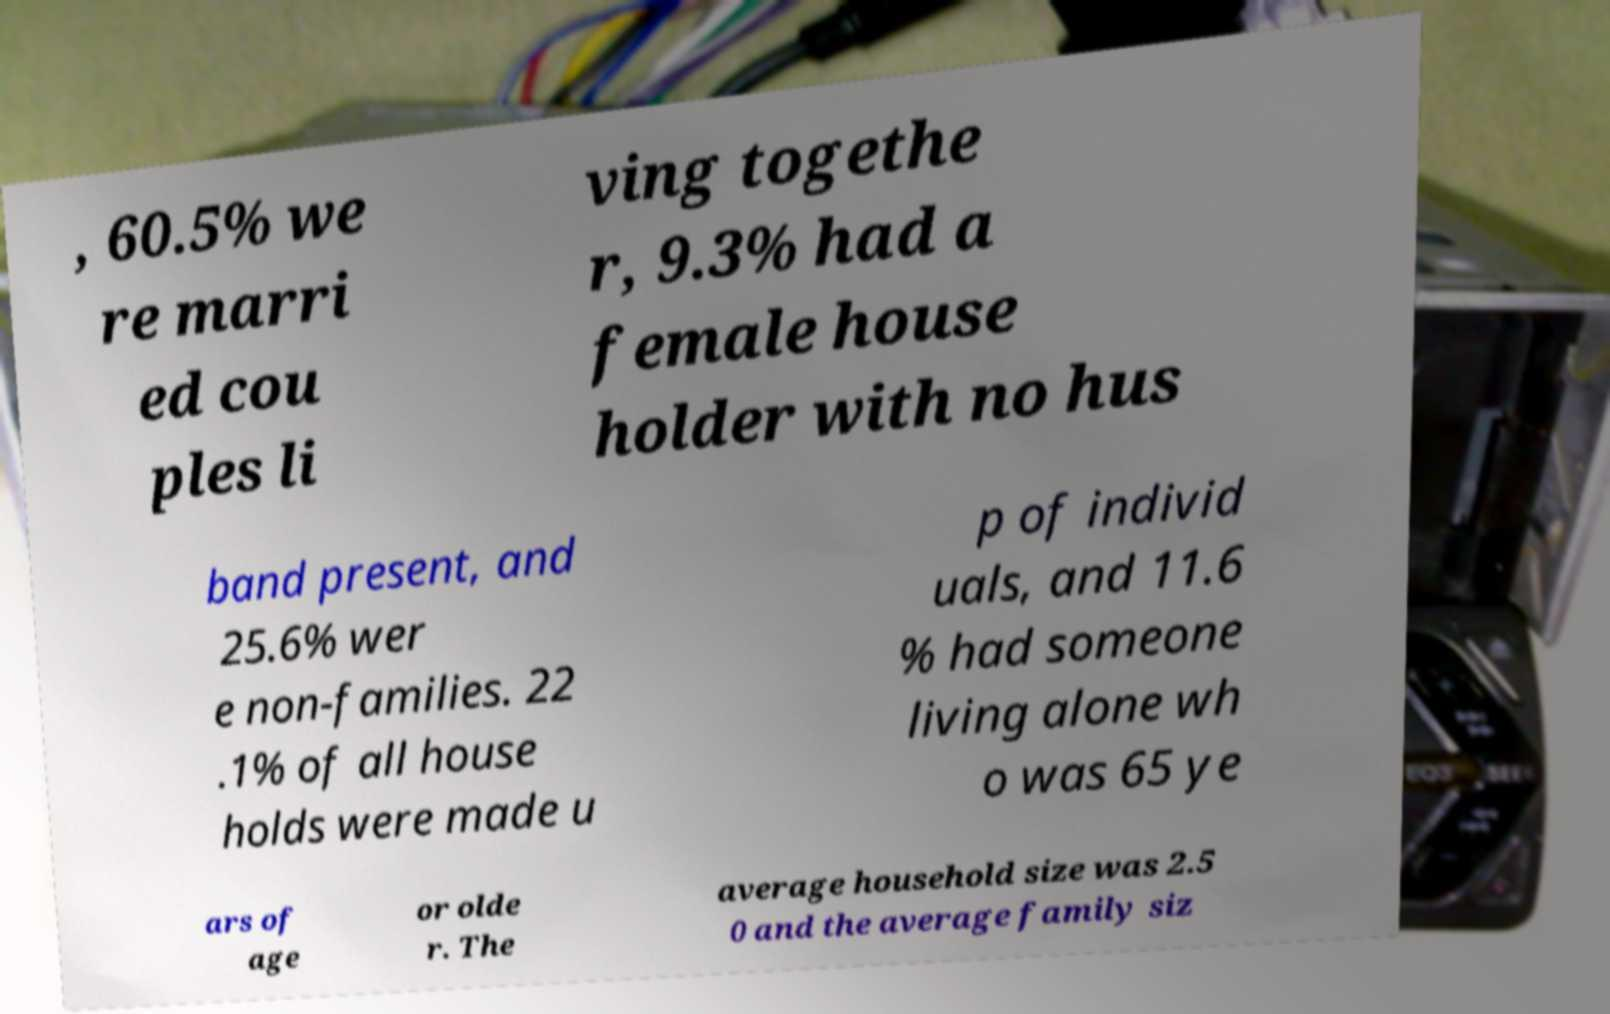What messages or text are displayed in this image? I need them in a readable, typed format. , 60.5% we re marri ed cou ples li ving togethe r, 9.3% had a female house holder with no hus band present, and 25.6% wer e non-families. 22 .1% of all house holds were made u p of individ uals, and 11.6 % had someone living alone wh o was 65 ye ars of age or olde r. The average household size was 2.5 0 and the average family siz 